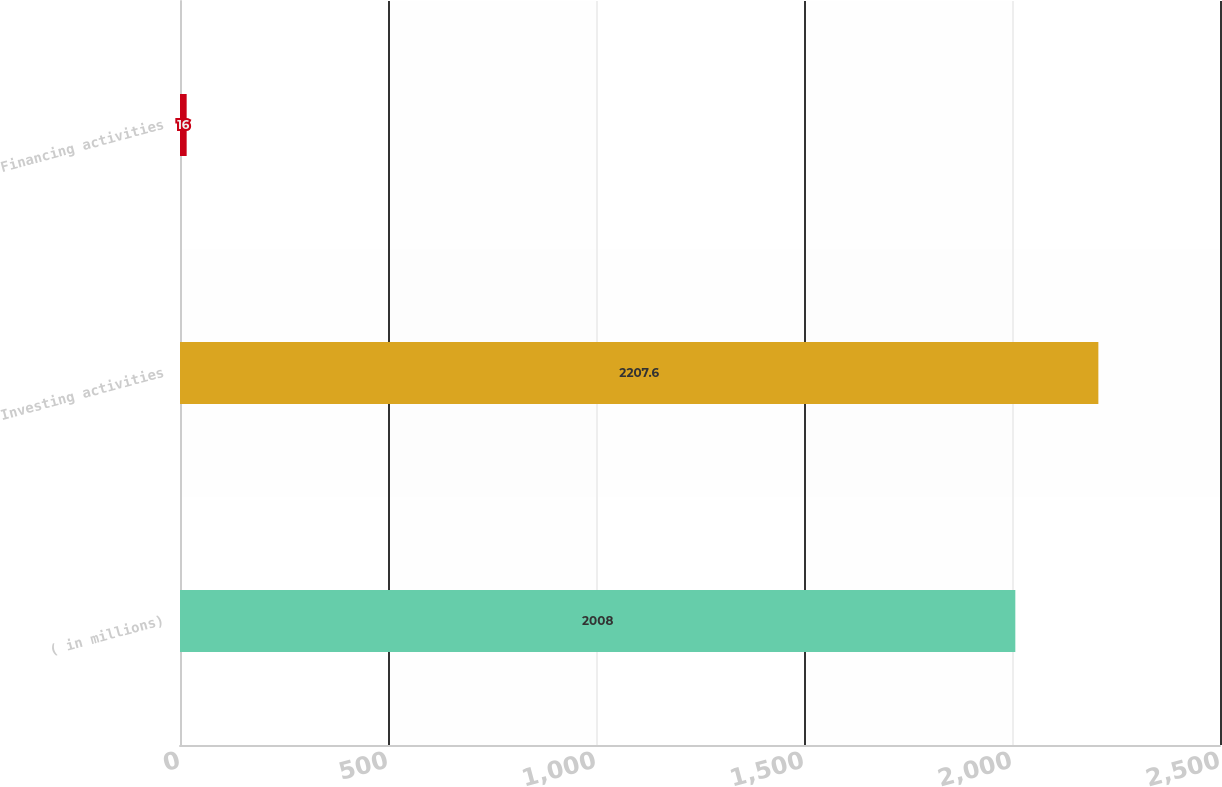<chart> <loc_0><loc_0><loc_500><loc_500><bar_chart><fcel>( in millions)<fcel>Investing activities<fcel>Financing activities<nl><fcel>2008<fcel>2207.6<fcel>16<nl></chart> 